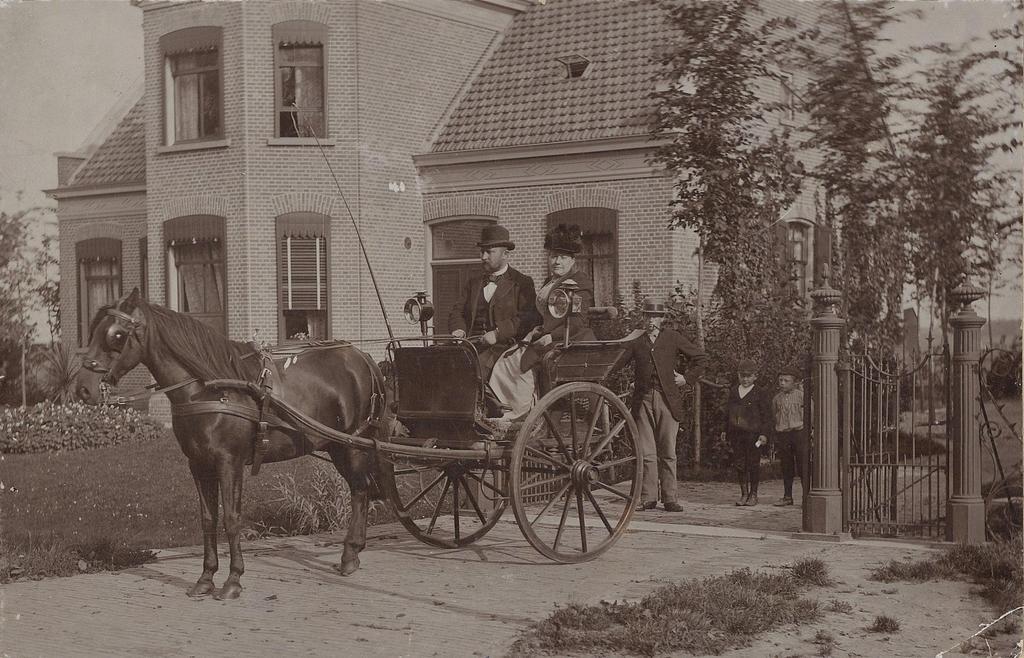In one or two sentences, can you explain what this image depicts? In this image we can see black and white picture of two persons sitting in a horse cart with lights. On the right side of the image we can see some persons standing on the ground, gate and poles. On the left side of the image we can see flowers on the plants. In the background of the image we can see building with windows, roof, group of trees and the sky. 